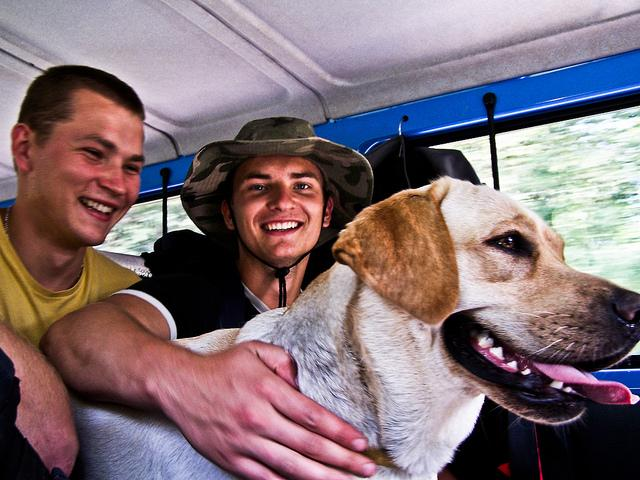What is touching the dog? hand 